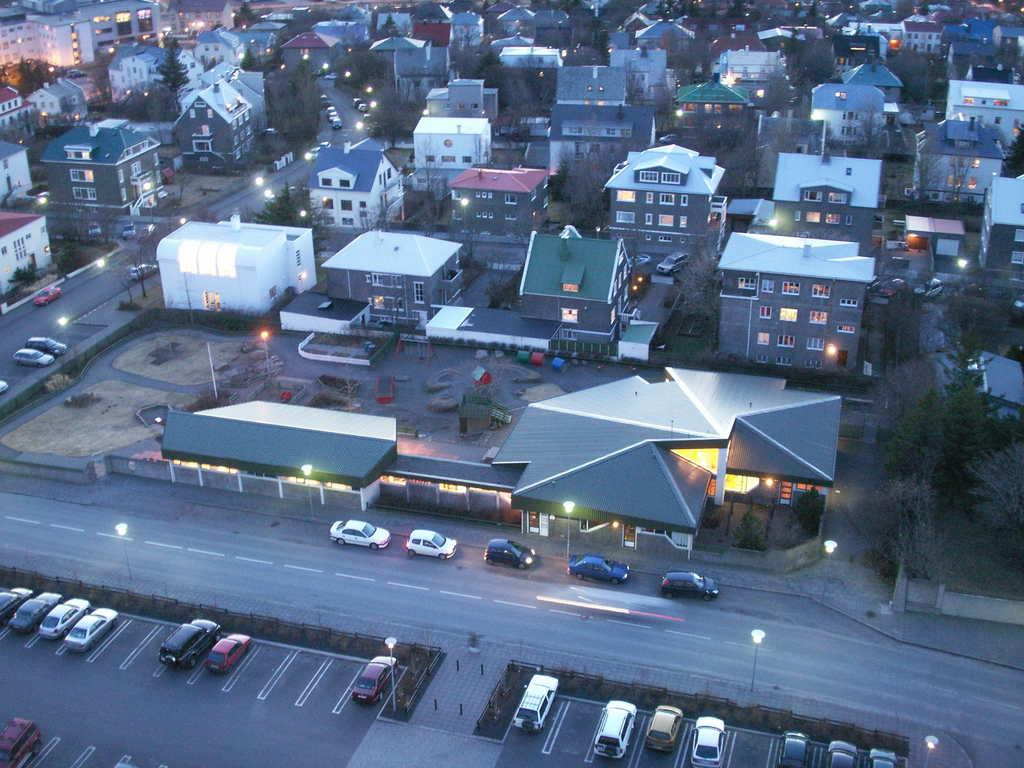What type of structures can be seen in the image? There are buildings in the image. What other natural elements are present in the image? There are trees in the image. What type of lighting is visible in the image? There are street lights in the image. What type of transportation is visible in the image? There are vehicles on the roads and parked at the bottom of the image. What scent can be detected in the image? There is no information about scents in the image, as it only provides visual information. 